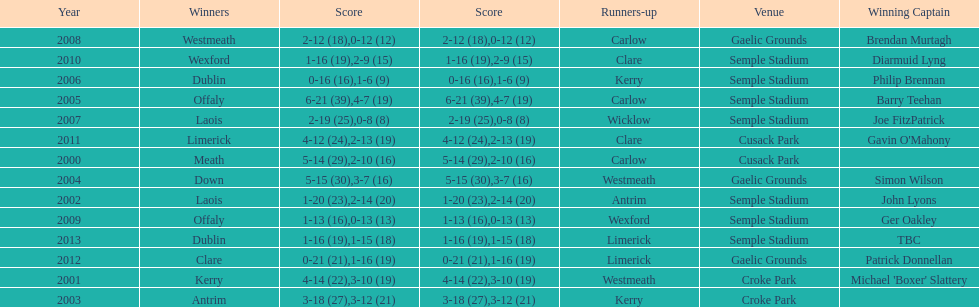Who was the victor post 2007? Laois. 